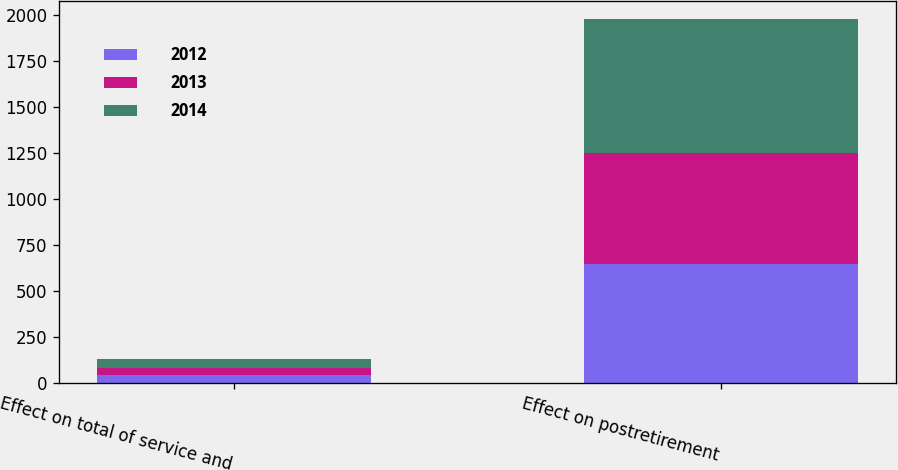Convert chart to OTSL. <chart><loc_0><loc_0><loc_500><loc_500><stacked_bar_chart><ecel><fcel>Effect on total of service and<fcel>Effect on postretirement<nl><fcel>2012<fcel>39<fcel>646<nl><fcel>2013<fcel>43<fcel>601<nl><fcel>2014<fcel>44<fcel>727<nl></chart> 